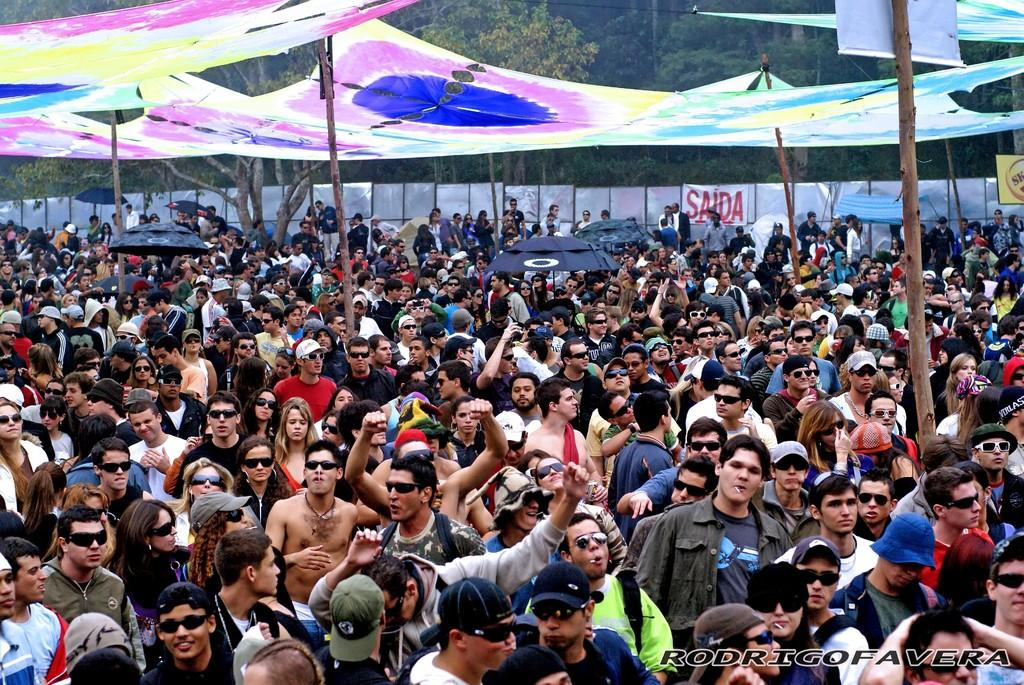How many people are in the image? There are many people in the image. What can be seen in the background of the image? There is a fence visible in the image, and trees are around the area. Can you describe an object present in the image? There is a cloth present in the image. Where is the faucet located in the image? There is no faucet present in the image. What type of tin is being used by the people in the image? There is no tin visible or mentioned in the image. 